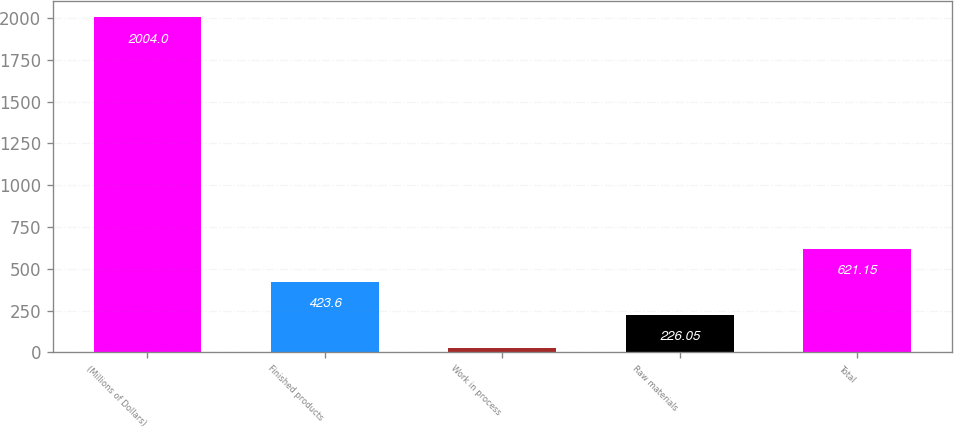Convert chart. <chart><loc_0><loc_0><loc_500><loc_500><bar_chart><fcel>(Millions of Dollars)<fcel>Finished products<fcel>Work in process<fcel>Raw materials<fcel>Total<nl><fcel>2004<fcel>423.6<fcel>28.5<fcel>226.05<fcel>621.15<nl></chart> 